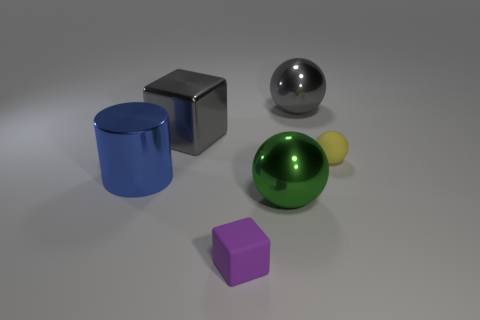Add 2 tiny gray metallic spheres. How many objects exist? 8 Subtract all cylinders. How many objects are left? 5 Add 5 big spheres. How many big spheres are left? 7 Add 4 large shiny things. How many large shiny things exist? 8 Subtract 0 blue balls. How many objects are left? 6 Subtract all tiny cyan matte objects. Subtract all big green metal things. How many objects are left? 5 